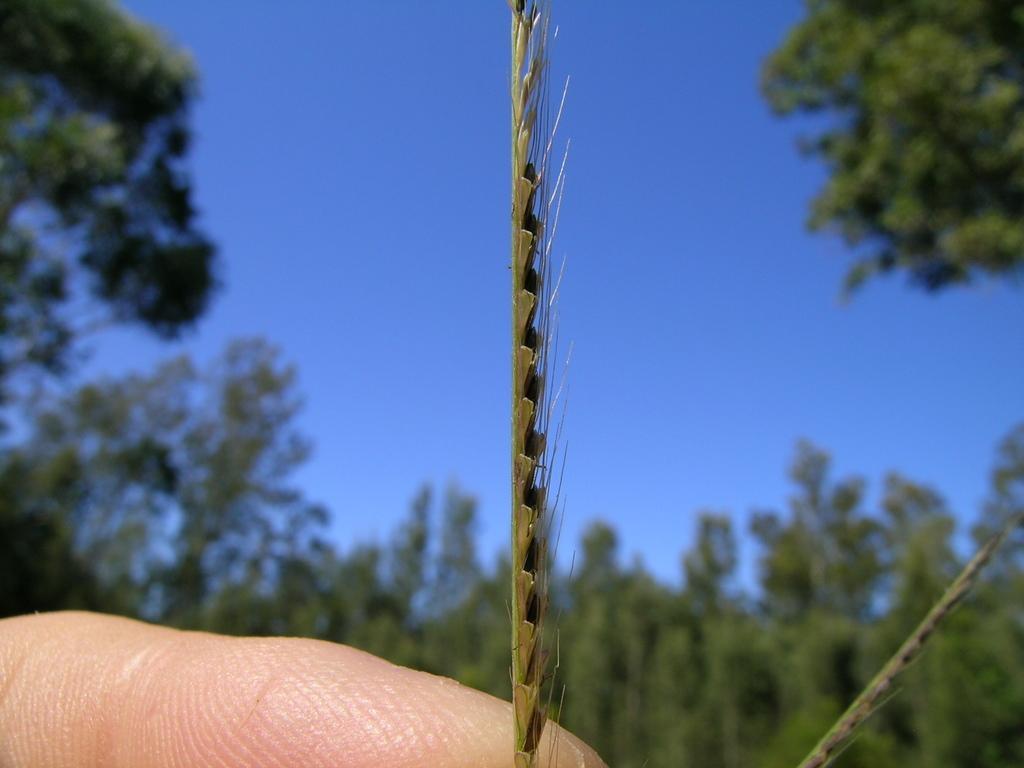How would you summarize this image in a sentence or two? In this image there is a finger and a grass, in the background there are trees and the blue sky and it is blurred. 